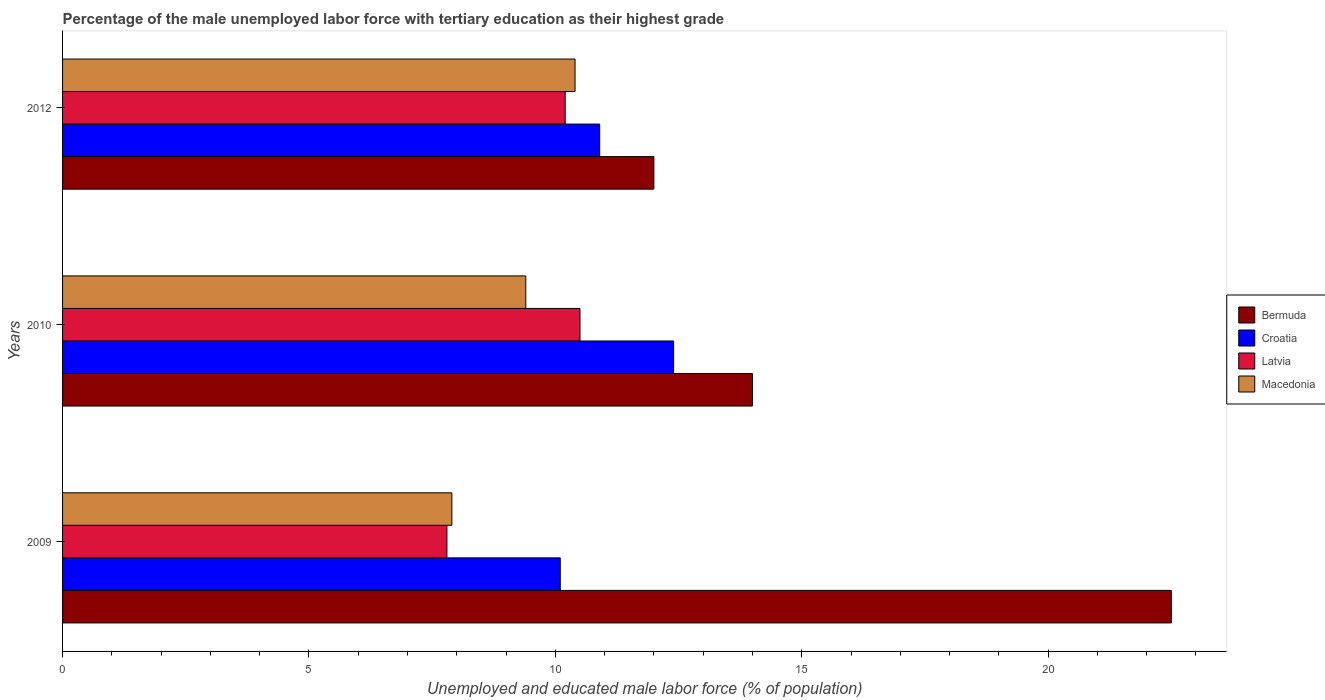How many different coloured bars are there?
Provide a short and direct response. 4. How many bars are there on the 2nd tick from the top?
Offer a very short reply. 4. How many bars are there on the 3rd tick from the bottom?
Keep it short and to the point. 4. What is the label of the 1st group of bars from the top?
Give a very brief answer. 2012. In how many cases, is the number of bars for a given year not equal to the number of legend labels?
Keep it short and to the point. 0. What is the percentage of the unemployed male labor force with tertiary education in Macedonia in 2012?
Keep it short and to the point. 10.4. Across all years, what is the minimum percentage of the unemployed male labor force with tertiary education in Bermuda?
Provide a short and direct response. 12. In which year was the percentage of the unemployed male labor force with tertiary education in Croatia maximum?
Ensure brevity in your answer.  2010. What is the total percentage of the unemployed male labor force with tertiary education in Latvia in the graph?
Your answer should be compact. 28.5. What is the difference between the percentage of the unemployed male labor force with tertiary education in Macedonia in 2009 and that in 2010?
Provide a succinct answer. -1.5. What is the difference between the percentage of the unemployed male labor force with tertiary education in Latvia in 2010 and the percentage of the unemployed male labor force with tertiary education in Croatia in 2009?
Your answer should be compact. 0.4. What is the average percentage of the unemployed male labor force with tertiary education in Latvia per year?
Ensure brevity in your answer.  9.5. In the year 2009, what is the difference between the percentage of the unemployed male labor force with tertiary education in Croatia and percentage of the unemployed male labor force with tertiary education in Latvia?
Your response must be concise. 2.3. What is the ratio of the percentage of the unemployed male labor force with tertiary education in Macedonia in 2010 to that in 2012?
Ensure brevity in your answer.  0.9. Is the percentage of the unemployed male labor force with tertiary education in Latvia in 2009 less than that in 2010?
Provide a succinct answer. Yes. Is the difference between the percentage of the unemployed male labor force with tertiary education in Croatia in 2009 and 2012 greater than the difference between the percentage of the unemployed male labor force with tertiary education in Latvia in 2009 and 2012?
Your response must be concise. Yes. What is the difference between the highest and the second highest percentage of the unemployed male labor force with tertiary education in Macedonia?
Give a very brief answer. 1. What is the difference between the highest and the lowest percentage of the unemployed male labor force with tertiary education in Macedonia?
Keep it short and to the point. 2.5. Is it the case that in every year, the sum of the percentage of the unemployed male labor force with tertiary education in Croatia and percentage of the unemployed male labor force with tertiary education in Bermuda is greater than the sum of percentage of the unemployed male labor force with tertiary education in Macedonia and percentage of the unemployed male labor force with tertiary education in Latvia?
Offer a very short reply. Yes. What does the 2nd bar from the top in 2012 represents?
Ensure brevity in your answer.  Latvia. What does the 3rd bar from the bottom in 2012 represents?
Provide a short and direct response. Latvia. Is it the case that in every year, the sum of the percentage of the unemployed male labor force with tertiary education in Bermuda and percentage of the unemployed male labor force with tertiary education in Latvia is greater than the percentage of the unemployed male labor force with tertiary education in Macedonia?
Offer a very short reply. Yes. Does the graph contain any zero values?
Give a very brief answer. No. Where does the legend appear in the graph?
Offer a very short reply. Center right. How many legend labels are there?
Make the answer very short. 4. How are the legend labels stacked?
Make the answer very short. Vertical. What is the title of the graph?
Ensure brevity in your answer.  Percentage of the male unemployed labor force with tertiary education as their highest grade. Does "Senegal" appear as one of the legend labels in the graph?
Your answer should be compact. No. What is the label or title of the X-axis?
Provide a succinct answer. Unemployed and educated male labor force (% of population). What is the label or title of the Y-axis?
Keep it short and to the point. Years. What is the Unemployed and educated male labor force (% of population) of Croatia in 2009?
Keep it short and to the point. 10.1. What is the Unemployed and educated male labor force (% of population) of Latvia in 2009?
Keep it short and to the point. 7.8. What is the Unemployed and educated male labor force (% of population) in Macedonia in 2009?
Offer a very short reply. 7.9. What is the Unemployed and educated male labor force (% of population) in Bermuda in 2010?
Give a very brief answer. 14. What is the Unemployed and educated male labor force (% of population) of Croatia in 2010?
Give a very brief answer. 12.4. What is the Unemployed and educated male labor force (% of population) of Latvia in 2010?
Give a very brief answer. 10.5. What is the Unemployed and educated male labor force (% of population) in Macedonia in 2010?
Keep it short and to the point. 9.4. What is the Unemployed and educated male labor force (% of population) of Bermuda in 2012?
Ensure brevity in your answer.  12. What is the Unemployed and educated male labor force (% of population) in Croatia in 2012?
Provide a short and direct response. 10.9. What is the Unemployed and educated male labor force (% of population) in Latvia in 2012?
Offer a very short reply. 10.2. What is the Unemployed and educated male labor force (% of population) of Macedonia in 2012?
Make the answer very short. 10.4. Across all years, what is the maximum Unemployed and educated male labor force (% of population) in Croatia?
Give a very brief answer. 12.4. Across all years, what is the maximum Unemployed and educated male labor force (% of population) in Macedonia?
Give a very brief answer. 10.4. Across all years, what is the minimum Unemployed and educated male labor force (% of population) in Croatia?
Give a very brief answer. 10.1. Across all years, what is the minimum Unemployed and educated male labor force (% of population) in Latvia?
Provide a succinct answer. 7.8. Across all years, what is the minimum Unemployed and educated male labor force (% of population) of Macedonia?
Offer a terse response. 7.9. What is the total Unemployed and educated male labor force (% of population) of Bermuda in the graph?
Make the answer very short. 48.5. What is the total Unemployed and educated male labor force (% of population) of Croatia in the graph?
Your response must be concise. 33.4. What is the total Unemployed and educated male labor force (% of population) in Macedonia in the graph?
Your answer should be very brief. 27.7. What is the difference between the Unemployed and educated male labor force (% of population) of Bermuda in 2009 and that in 2010?
Offer a terse response. 8.5. What is the difference between the Unemployed and educated male labor force (% of population) in Croatia in 2009 and that in 2010?
Make the answer very short. -2.3. What is the difference between the Unemployed and educated male labor force (% of population) in Latvia in 2009 and that in 2010?
Ensure brevity in your answer.  -2.7. What is the difference between the Unemployed and educated male labor force (% of population) in Macedonia in 2009 and that in 2010?
Your response must be concise. -1.5. What is the difference between the Unemployed and educated male labor force (% of population) in Latvia in 2009 and that in 2012?
Offer a very short reply. -2.4. What is the difference between the Unemployed and educated male labor force (% of population) in Macedonia in 2009 and that in 2012?
Give a very brief answer. -2.5. What is the difference between the Unemployed and educated male labor force (% of population) of Latvia in 2010 and that in 2012?
Your answer should be very brief. 0.3. What is the difference between the Unemployed and educated male labor force (% of population) of Bermuda in 2009 and the Unemployed and educated male labor force (% of population) of Latvia in 2010?
Provide a short and direct response. 12. What is the difference between the Unemployed and educated male labor force (% of population) of Croatia in 2009 and the Unemployed and educated male labor force (% of population) of Latvia in 2010?
Give a very brief answer. -0.4. What is the difference between the Unemployed and educated male labor force (% of population) in Croatia in 2009 and the Unemployed and educated male labor force (% of population) in Macedonia in 2010?
Your answer should be compact. 0.7. What is the difference between the Unemployed and educated male labor force (% of population) in Bermuda in 2009 and the Unemployed and educated male labor force (% of population) in Croatia in 2012?
Your answer should be very brief. 11.6. What is the difference between the Unemployed and educated male labor force (% of population) in Latvia in 2009 and the Unemployed and educated male labor force (% of population) in Macedonia in 2012?
Provide a short and direct response. -2.6. What is the difference between the Unemployed and educated male labor force (% of population) of Bermuda in 2010 and the Unemployed and educated male labor force (% of population) of Croatia in 2012?
Provide a short and direct response. 3.1. What is the difference between the Unemployed and educated male labor force (% of population) of Bermuda in 2010 and the Unemployed and educated male labor force (% of population) of Macedonia in 2012?
Your response must be concise. 3.6. What is the difference between the Unemployed and educated male labor force (% of population) of Latvia in 2010 and the Unemployed and educated male labor force (% of population) of Macedonia in 2012?
Provide a succinct answer. 0.1. What is the average Unemployed and educated male labor force (% of population) in Bermuda per year?
Your answer should be compact. 16.17. What is the average Unemployed and educated male labor force (% of population) of Croatia per year?
Ensure brevity in your answer.  11.13. What is the average Unemployed and educated male labor force (% of population) of Latvia per year?
Give a very brief answer. 9.5. What is the average Unemployed and educated male labor force (% of population) in Macedonia per year?
Ensure brevity in your answer.  9.23. In the year 2009, what is the difference between the Unemployed and educated male labor force (% of population) of Bermuda and Unemployed and educated male labor force (% of population) of Croatia?
Your answer should be compact. 12.4. In the year 2009, what is the difference between the Unemployed and educated male labor force (% of population) of Bermuda and Unemployed and educated male labor force (% of population) of Macedonia?
Provide a succinct answer. 14.6. In the year 2009, what is the difference between the Unemployed and educated male labor force (% of population) of Croatia and Unemployed and educated male labor force (% of population) of Latvia?
Keep it short and to the point. 2.3. In the year 2010, what is the difference between the Unemployed and educated male labor force (% of population) of Bermuda and Unemployed and educated male labor force (% of population) of Macedonia?
Your answer should be very brief. 4.6. In the year 2010, what is the difference between the Unemployed and educated male labor force (% of population) in Croatia and Unemployed and educated male labor force (% of population) in Latvia?
Your answer should be compact. 1.9. In the year 2010, what is the difference between the Unemployed and educated male labor force (% of population) in Croatia and Unemployed and educated male labor force (% of population) in Macedonia?
Your answer should be compact. 3. In the year 2010, what is the difference between the Unemployed and educated male labor force (% of population) in Latvia and Unemployed and educated male labor force (% of population) in Macedonia?
Provide a succinct answer. 1.1. In the year 2012, what is the difference between the Unemployed and educated male labor force (% of population) in Bermuda and Unemployed and educated male labor force (% of population) in Croatia?
Your response must be concise. 1.1. In the year 2012, what is the difference between the Unemployed and educated male labor force (% of population) in Bermuda and Unemployed and educated male labor force (% of population) in Latvia?
Provide a succinct answer. 1.8. In the year 2012, what is the difference between the Unemployed and educated male labor force (% of population) of Croatia and Unemployed and educated male labor force (% of population) of Latvia?
Give a very brief answer. 0.7. What is the ratio of the Unemployed and educated male labor force (% of population) in Bermuda in 2009 to that in 2010?
Ensure brevity in your answer.  1.61. What is the ratio of the Unemployed and educated male labor force (% of population) in Croatia in 2009 to that in 2010?
Offer a terse response. 0.81. What is the ratio of the Unemployed and educated male labor force (% of population) of Latvia in 2009 to that in 2010?
Your answer should be compact. 0.74. What is the ratio of the Unemployed and educated male labor force (% of population) of Macedonia in 2009 to that in 2010?
Provide a succinct answer. 0.84. What is the ratio of the Unemployed and educated male labor force (% of population) of Bermuda in 2009 to that in 2012?
Keep it short and to the point. 1.88. What is the ratio of the Unemployed and educated male labor force (% of population) of Croatia in 2009 to that in 2012?
Provide a short and direct response. 0.93. What is the ratio of the Unemployed and educated male labor force (% of population) of Latvia in 2009 to that in 2012?
Ensure brevity in your answer.  0.76. What is the ratio of the Unemployed and educated male labor force (% of population) in Macedonia in 2009 to that in 2012?
Your response must be concise. 0.76. What is the ratio of the Unemployed and educated male labor force (% of population) in Croatia in 2010 to that in 2012?
Provide a short and direct response. 1.14. What is the ratio of the Unemployed and educated male labor force (% of population) of Latvia in 2010 to that in 2012?
Provide a short and direct response. 1.03. What is the ratio of the Unemployed and educated male labor force (% of population) of Macedonia in 2010 to that in 2012?
Provide a short and direct response. 0.9. What is the difference between the highest and the second highest Unemployed and educated male labor force (% of population) of Bermuda?
Provide a short and direct response. 8.5. What is the difference between the highest and the second highest Unemployed and educated male labor force (% of population) of Latvia?
Your response must be concise. 0.3. 